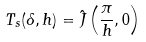<formula> <loc_0><loc_0><loc_500><loc_500>T _ { s } ( \delta , h ) = \hat { J } \left ( \frac { \pi } { h } , 0 \right )</formula> 